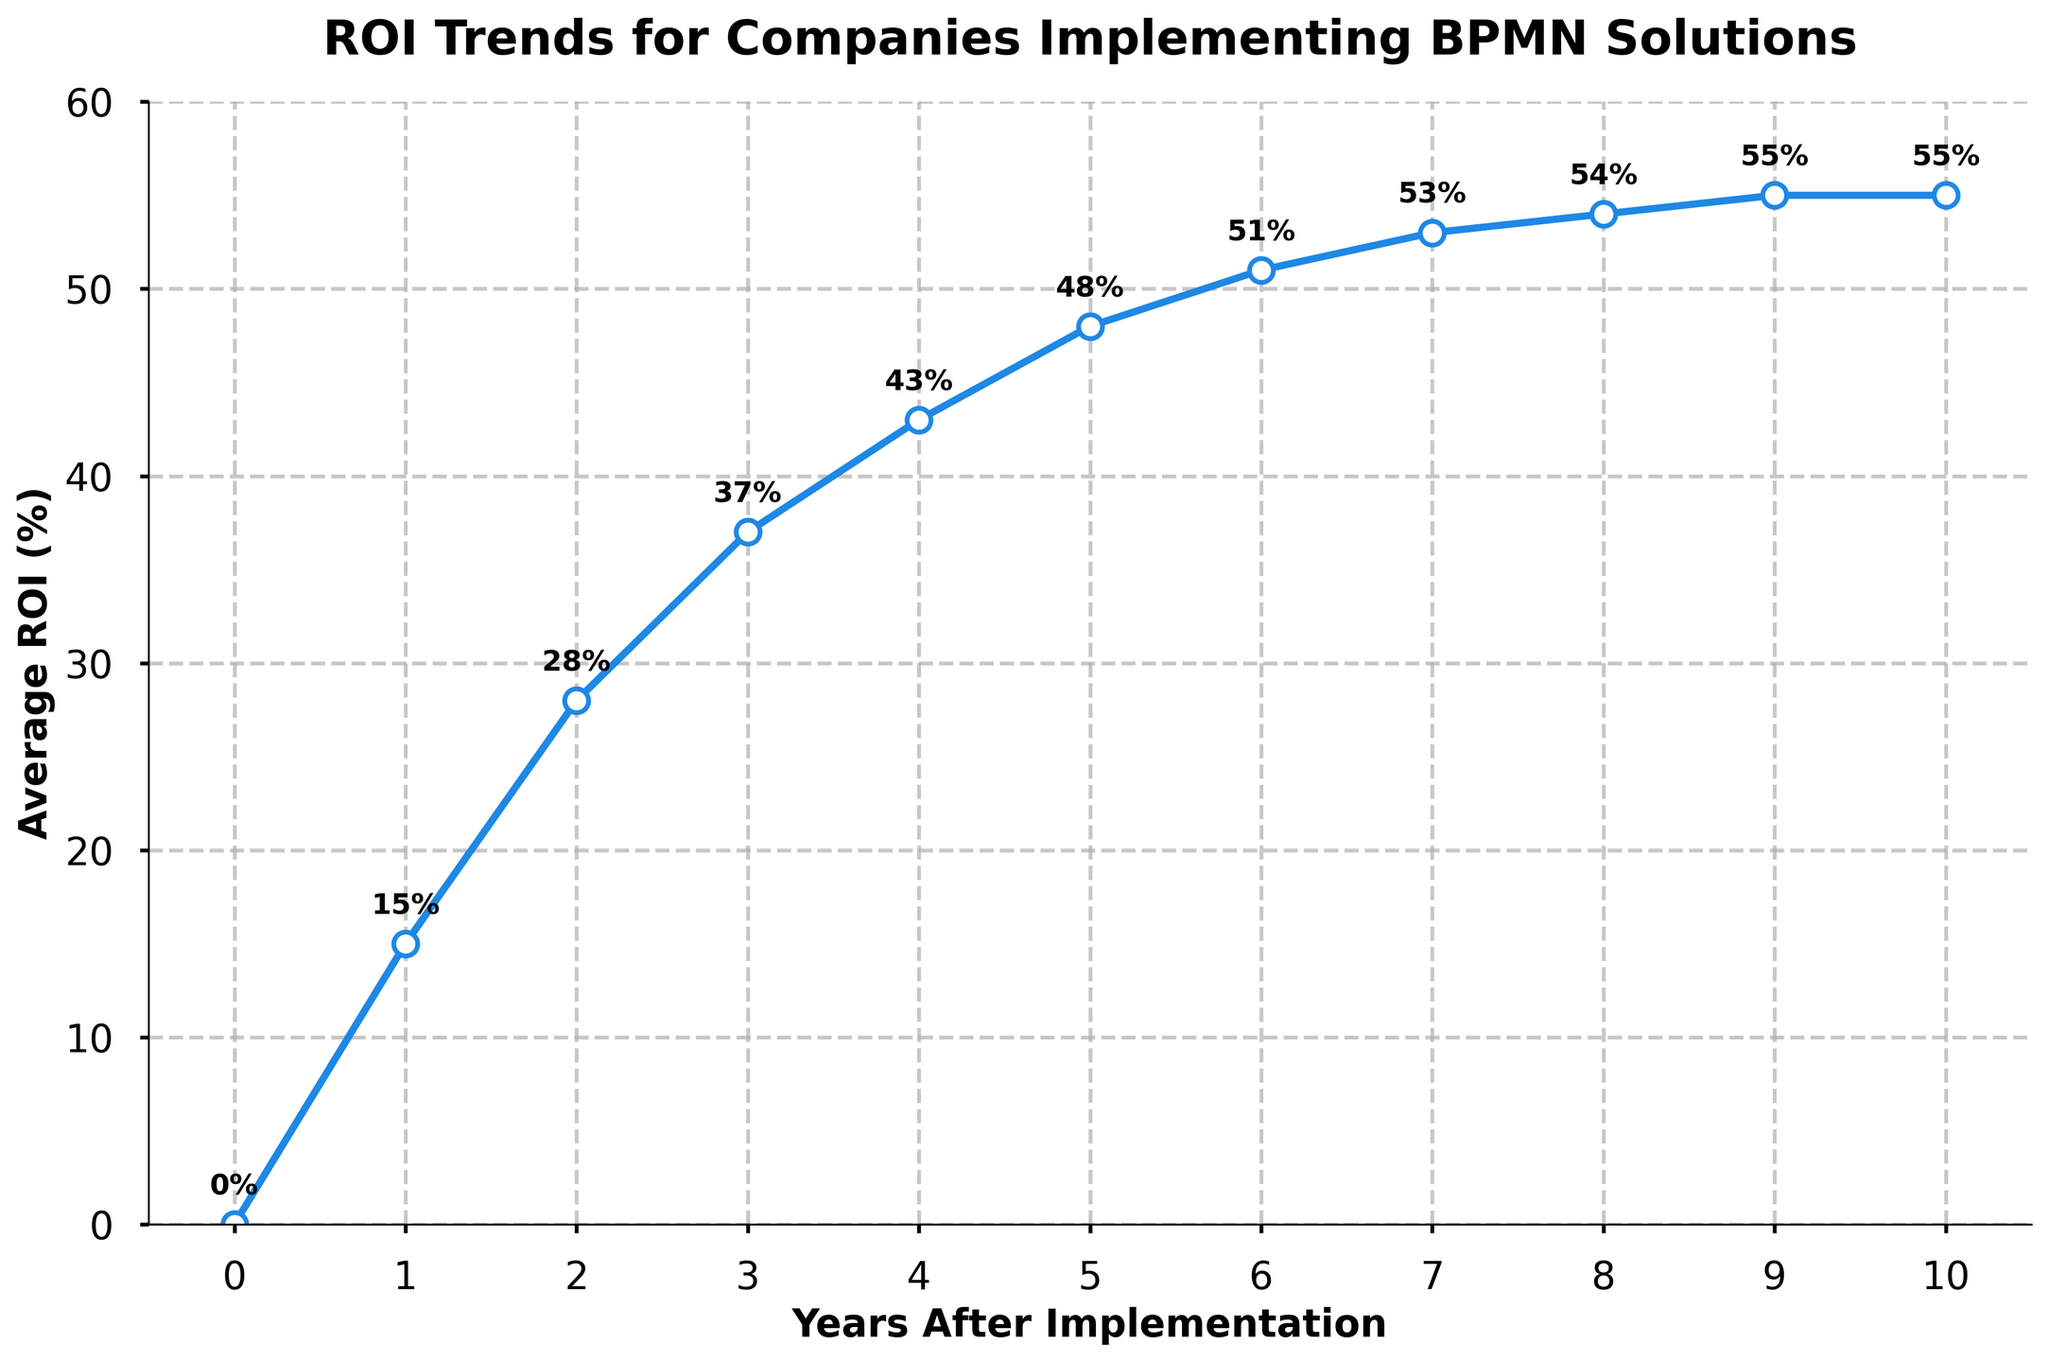What is the average ROI in the 4th year after implementing BPMN solutions? In the 4th year after implementation, the ROI value is indicated on the y-axis at the point corresponding to the 4th year on the x-axis. The exact value is 43%.
Answer: 43% By how much did the ROI increase from the 1st year to the 5th year after BPMN implementation? To find the increase, subtract the ROI value in the 1st year (15%) from the ROI value in the 5th year (48%). This gives 48% - 15% = 33%.
Answer: 33% What is the overall trend in ROI from year 0 to year 10? The ROI shows a continuous increase from year 0 at 0% to year 10 where it stabilizes at 55%.
Answer: Continuous increase Which year shows the highest ROI value? The highest value is visually identified at year 10, with an ROI value of 55%.
Answer: Year 10 Is there any year where the ROI did not increase compared to the previous year? By inspecting the graph, the ROI increases every year except between year 9 and year 10 where it remains the same at 55%.
Answer: Between year 9 and 10 What is the average ROI over the 10 years post-implementation? The average ROI is calculated by summing up all the ROI values (0 + 15 + 28 + 37 + 43 + 48 + 51 + 53 + 54 + 55 + 55 = 439) and dividing by the number of years (11). This gives an average ROI of 439/11 ≈ 39.9%.
Answer: 39.9% How does the ROI change between year 2 and year 4? The ROI in year 2 is 28% and in year 4 is 43%. The change is calculated as the difference, 43% - 28% = 15%.
Answer: 15% What is the difference in ROI between the 3rd and 7th year? The ROI in year 3 is 37% and in year 7 is 53%. The difference is 53% - 37% = 16%.
Answer: 16% How does the ROI trend change after year 7? By observing the chart, the ROI continues to increase but at a slower pace after year 7, reaching a plateau around 55% by year 10.
Answer: Slowed increase In which year did the ROI exceed 50%? From the chart, the ROI exceeds 50% in the 6th year after implementation, reaching 51%.
Answer: Year 6 